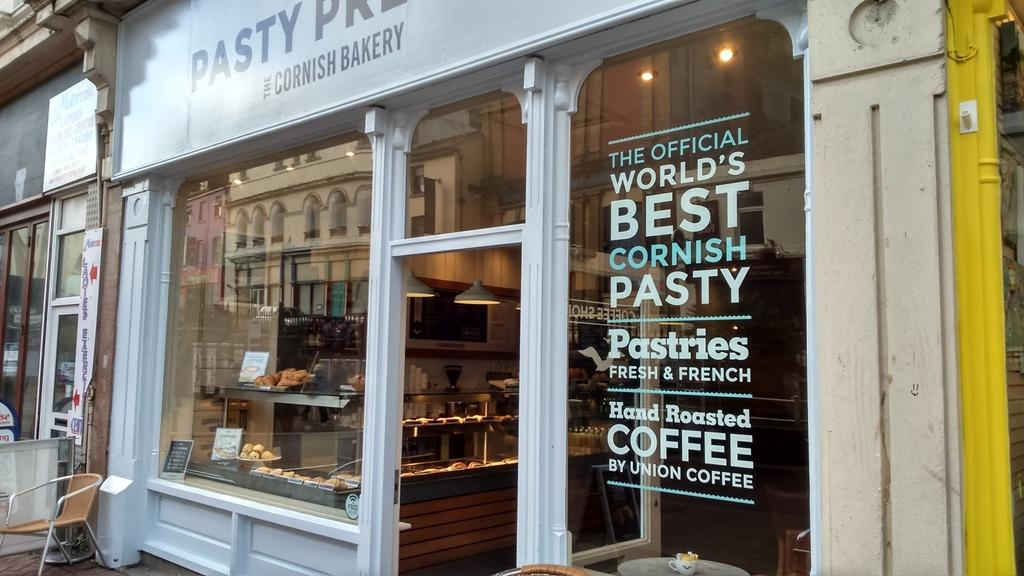<image>
Share a concise interpretation of the image provided. The front window of a bakery claims it has the wolds best Cornish pasty. 